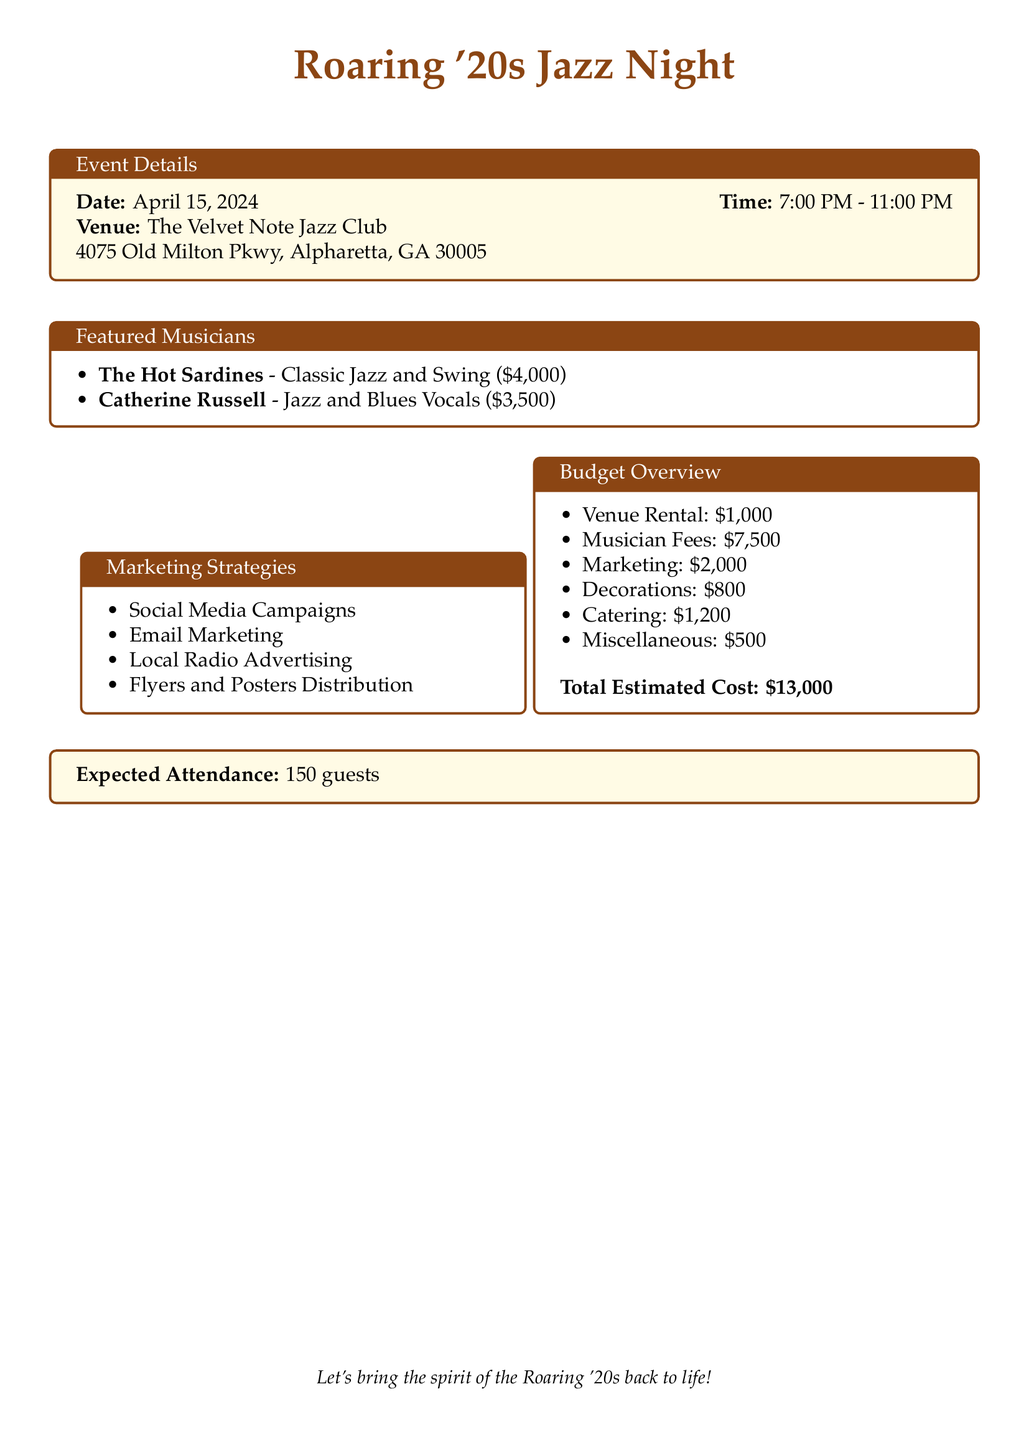What is the date of the event? The date of the event is specified in the document as April 15, 2024.
Answer: April 15, 2024 What is the total estimated cost? The total estimated cost is given at the end of the budget overview section as $13,000.
Answer: $13,000 Who is the featured musician known for classic jazz and swing? The document lists The Hot Sardines as the featured musician for classic jazz and swing.
Answer: The Hot Sardines What is the venue for the event? The venue is outlined in the event details and is The Velvet Note Jazz Club.
Answer: The Velvet Note Jazz Club How many guests are expected at the jazz night? The expected attendance is clearly mentioned in the document, detailing 150 guests.
Answer: 150 guests What type of advertising strategy is mentioned in the marketing section? The document lists local radio advertising as part of the marketing strategies utilized.
Answer: Local Radio Advertising What is one of the musician fees mentioned in the document? The document specifies Catherine Russell's fee as $3,500 in the featured musicians section.
Answer: $3,500 How many hours will the event run? The time specified for the event is from 7:00 PM to 11:00 PM, which is a total of 4 hours.
Answer: 4 hours Which element has the highest individual cost in the budget overview? The musician fees, totaling $7,500, are the highest individual cost in the budget overview.
Answer: $7,500 